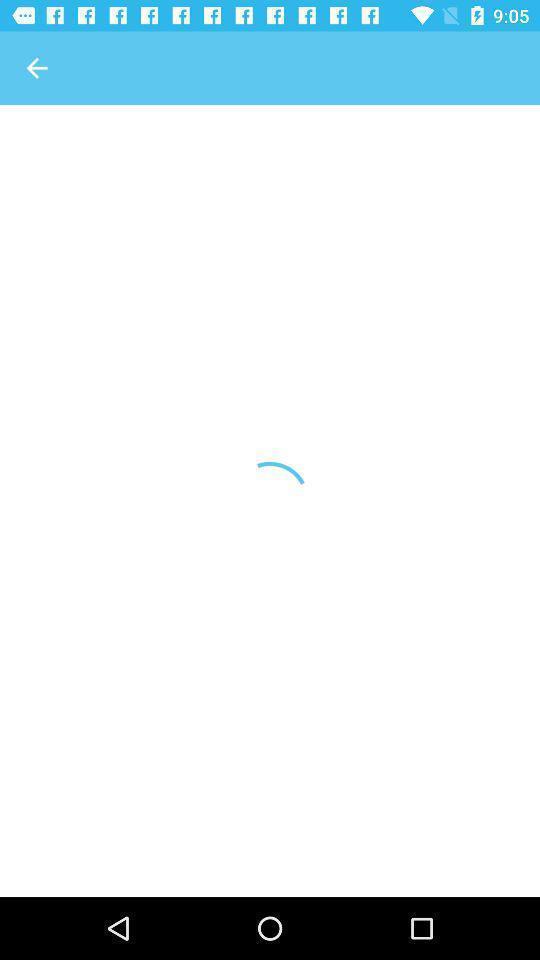Provide a description of this screenshot. Screen displaying a loading page. 